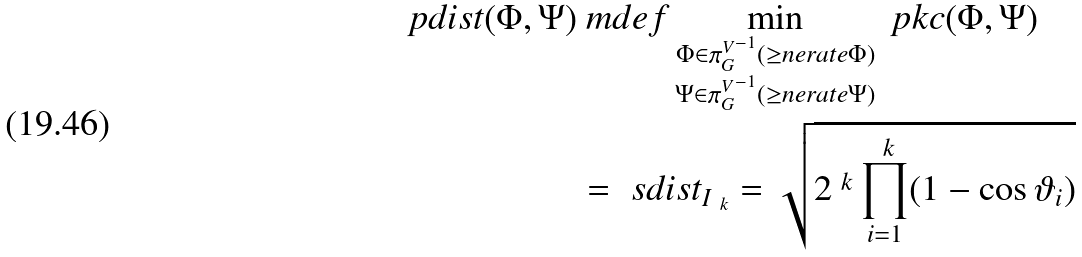Convert formula to latex. <formula><loc_0><loc_0><loc_500><loc_500>\ p d i s t ( \Phi , \Psi ) & \ m d e f \min _ { \substack { \Phi \in { \pi ^ { V } _ { G } } ^ { - 1 } ( \geq n e r a t e { \Phi } ) \\ \Psi \in { \pi ^ { V } _ { G } } ^ { - 1 } ( \geq n e r a t e { \Psi } ) } } \ p k c ( \Phi , \Psi ) \\ & = \ s d i s t _ { I _ { \ k } } = \sqrt { 2 ^ { \ k } \prod _ { i = 1 } ^ { \ k } ( 1 - \cos \vartheta _ { i } ) }</formula> 